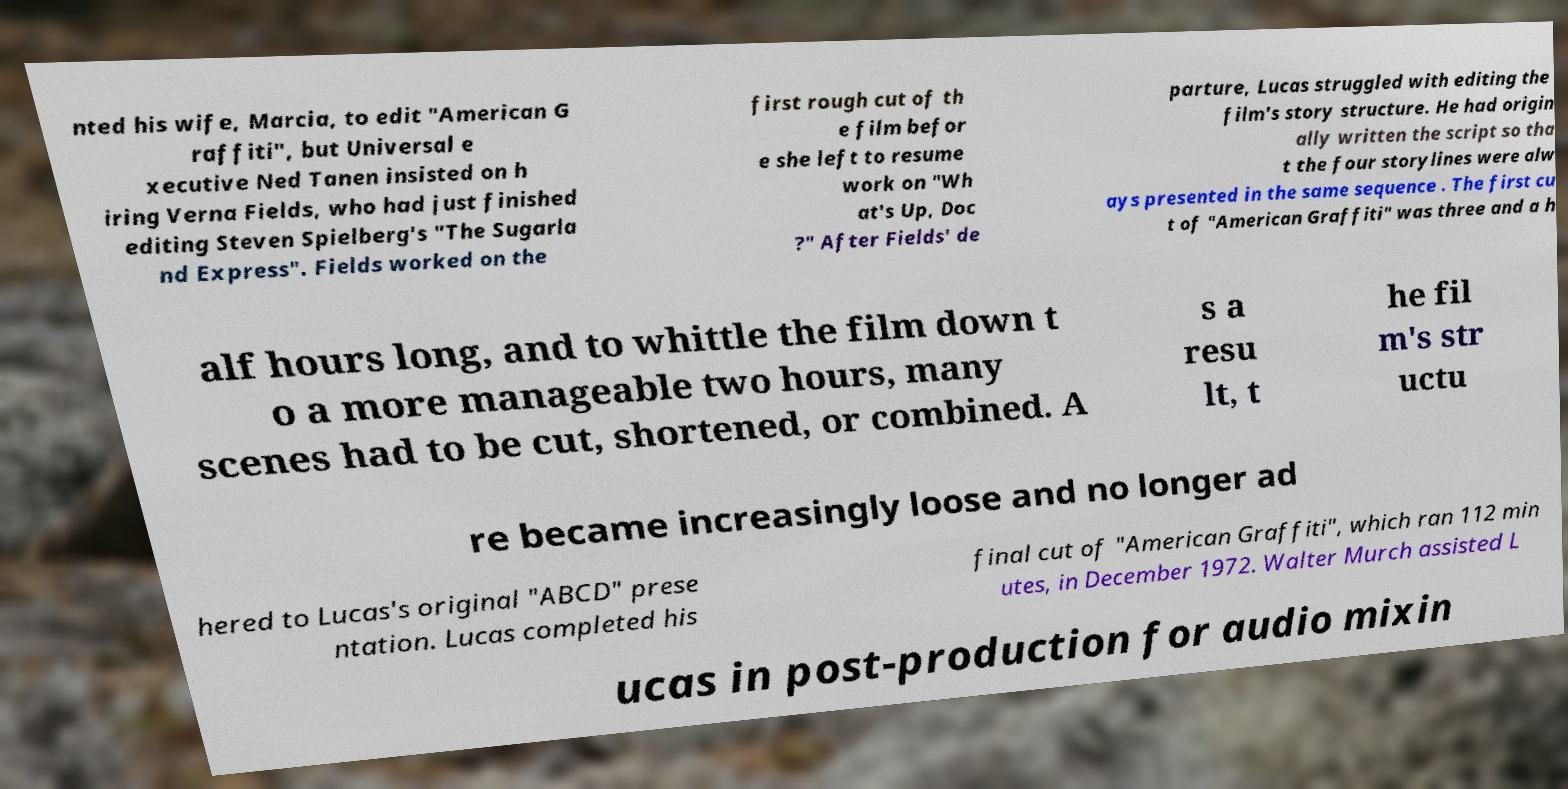For documentation purposes, I need the text within this image transcribed. Could you provide that? nted his wife, Marcia, to edit "American G raffiti", but Universal e xecutive Ned Tanen insisted on h iring Verna Fields, who had just finished editing Steven Spielberg's "The Sugarla nd Express". Fields worked on the first rough cut of th e film befor e she left to resume work on "Wh at's Up, Doc ?" After Fields' de parture, Lucas struggled with editing the film's story structure. He had origin ally written the script so tha t the four storylines were alw ays presented in the same sequence . The first cu t of "American Graffiti" was three and a h alf hours long, and to whittle the film down t o a more manageable two hours, many scenes had to be cut, shortened, or combined. A s a resu lt, t he fil m's str uctu re became increasingly loose and no longer ad hered to Lucas's original "ABCD" prese ntation. Lucas completed his final cut of "American Graffiti", which ran 112 min utes, in December 1972. Walter Murch assisted L ucas in post-production for audio mixin 